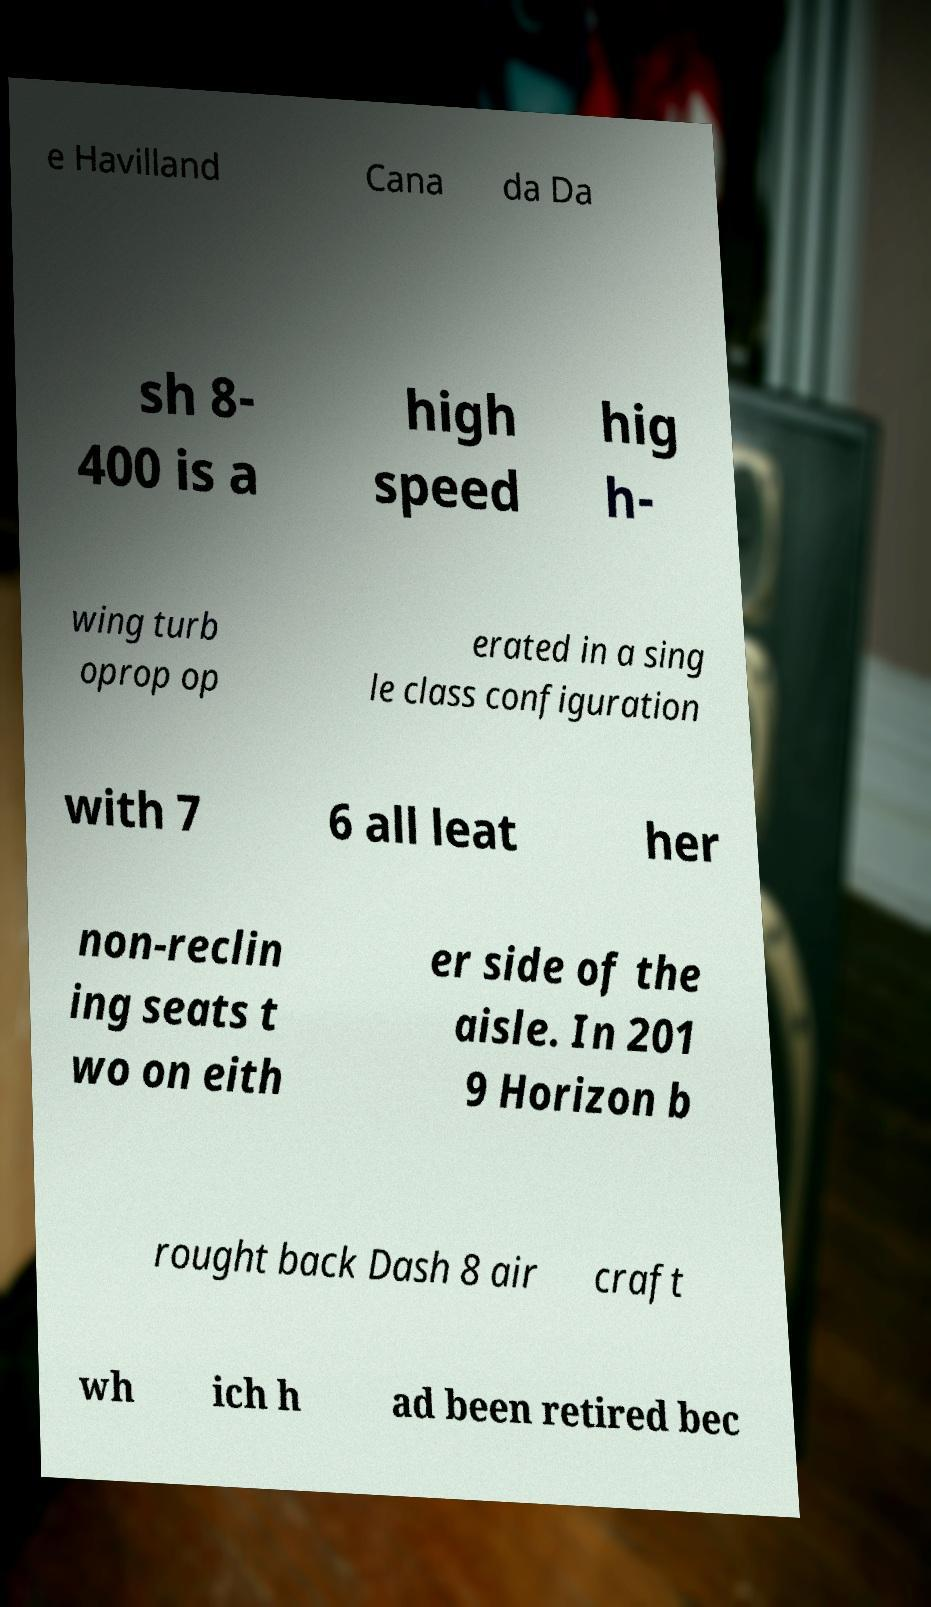Please read and relay the text visible in this image. What does it say? e Havilland Cana da Da sh 8- 400 is a high speed hig h- wing turb oprop op erated in a sing le class configuration with 7 6 all leat her non-reclin ing seats t wo on eith er side of the aisle. In 201 9 Horizon b rought back Dash 8 air craft wh ich h ad been retired bec 